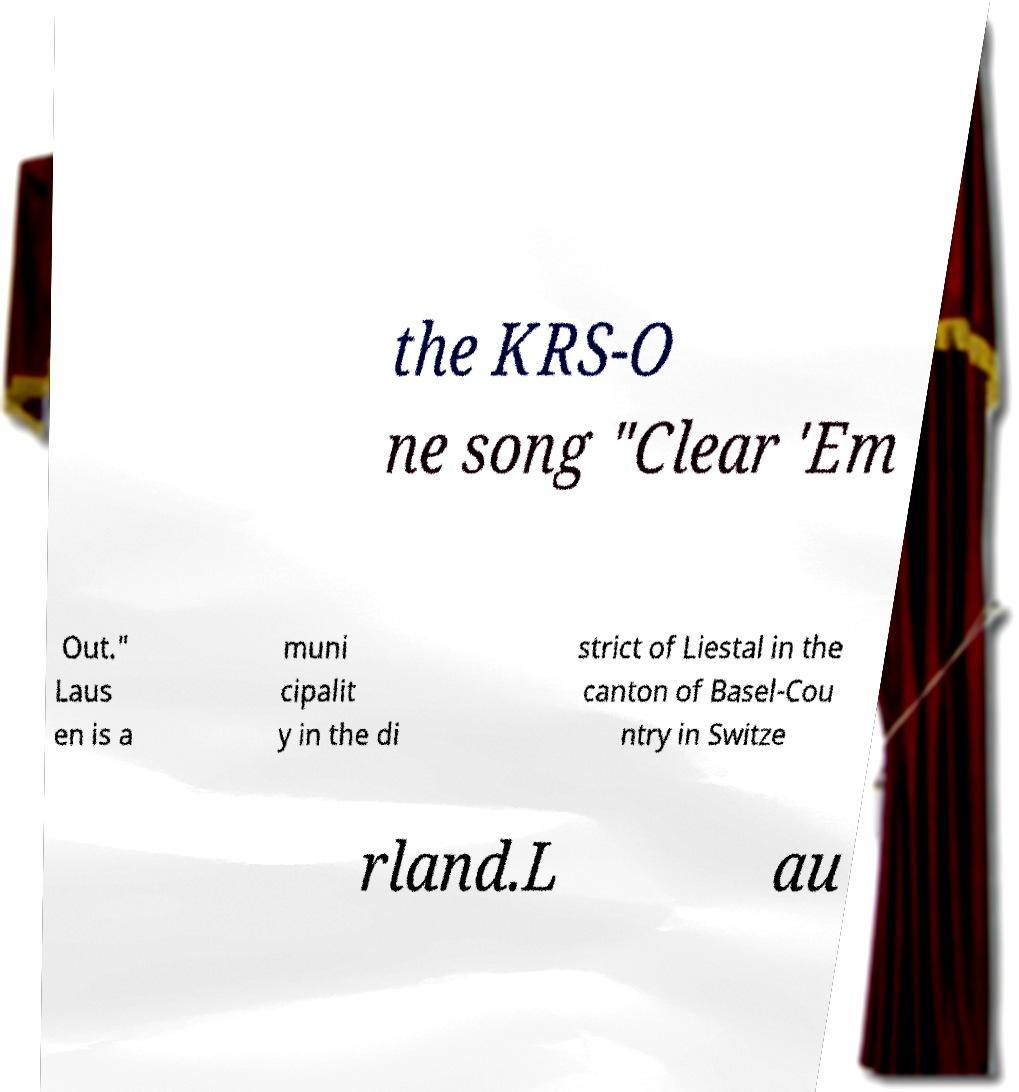Please read and relay the text visible in this image. What does it say? the KRS-O ne song "Clear 'Em Out." Laus en is a muni cipalit y in the di strict of Liestal in the canton of Basel-Cou ntry in Switze rland.L au 